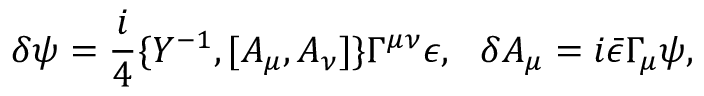<formula> <loc_0><loc_0><loc_500><loc_500>\delta \psi = \frac { i } { 4 } \{ Y ^ { - 1 } , [ A _ { \mu } , A _ { \nu } ] \} \Gamma ^ { \mu \nu } \epsilon , \delta A _ { \mu } = i \bar { \epsilon } \Gamma _ { \mu } \psi ,</formula> 